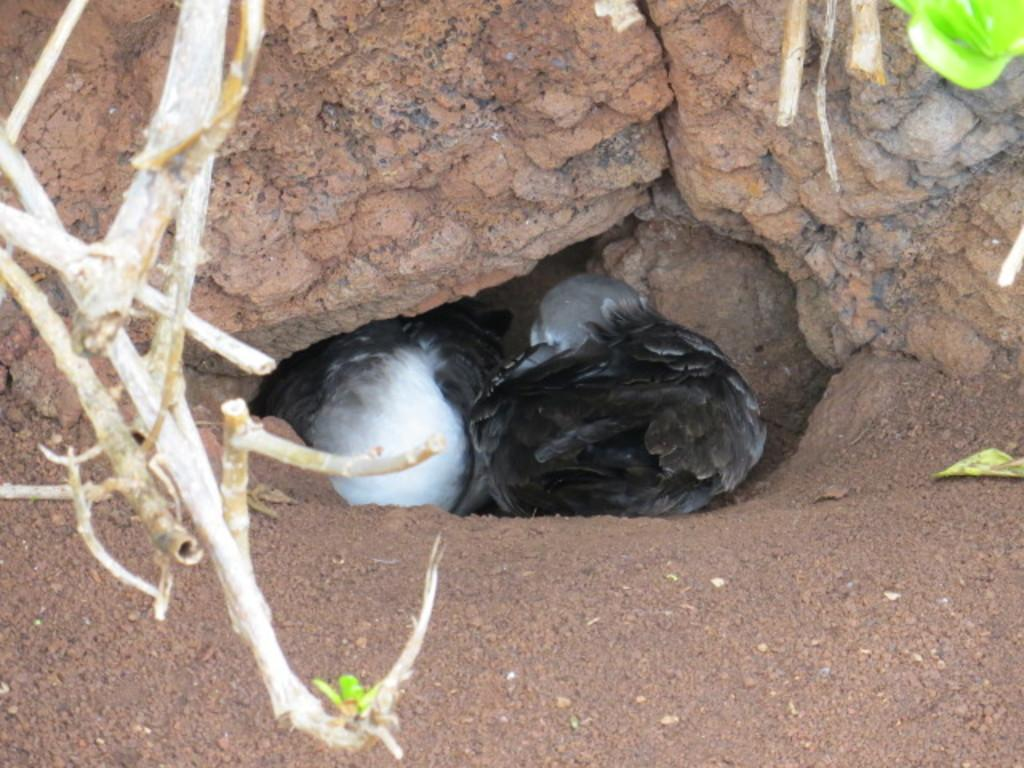What type of animals can be seen in the image? There are seabirds visible in the image. Where are the seabirds located in the image? The seabirds are under stones in the image. What might be visible on the left side of the image? There may be tree stems visible on the left side of the image. What type of waste can be seen in the image? There is no waste visible in the image; it features seabirds under stones and possibly tree stems. What force is being applied to the seabirds in the image? There is no force being applied to the seabirds in the image; they are simply resting under stones. 